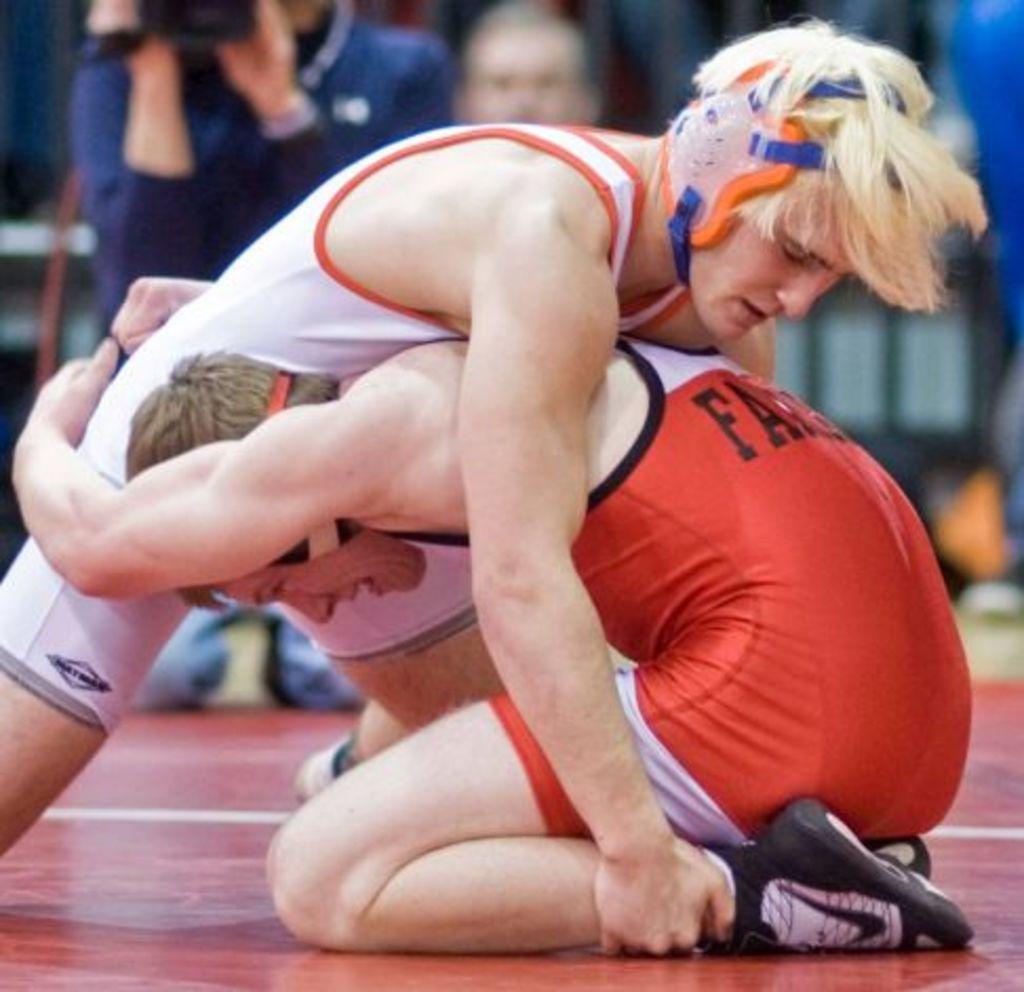What is the first letter of the name on his back?
Your response must be concise. F. 